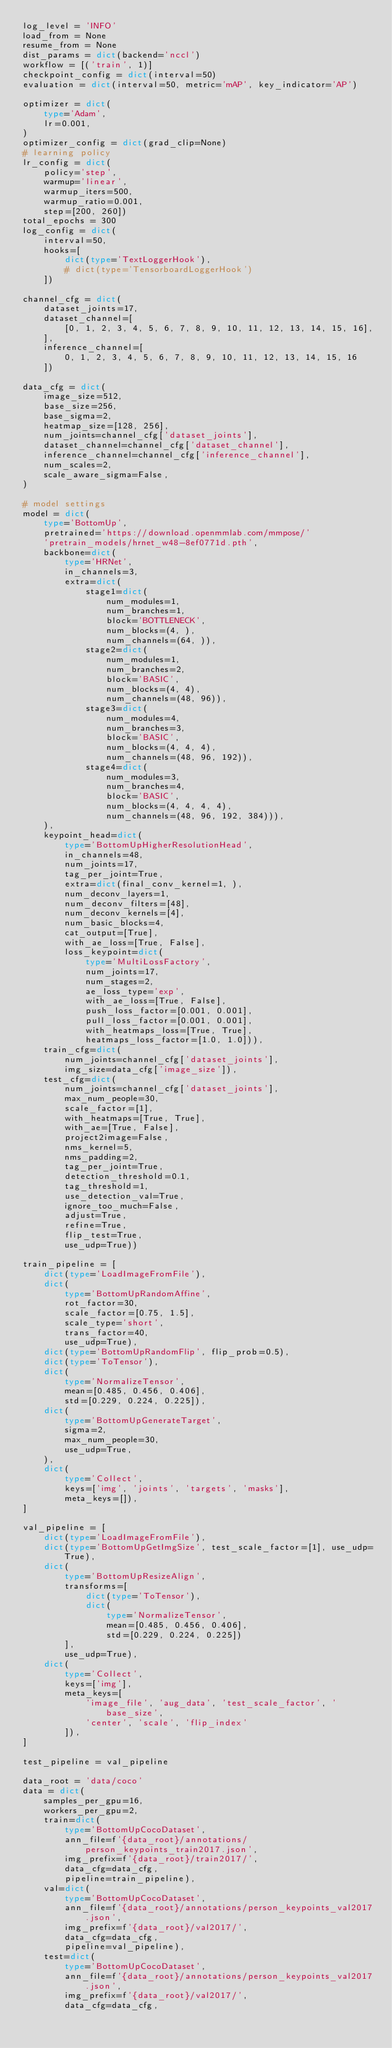<code> <loc_0><loc_0><loc_500><loc_500><_Python_>log_level = 'INFO'
load_from = None
resume_from = None
dist_params = dict(backend='nccl')
workflow = [('train', 1)]
checkpoint_config = dict(interval=50)
evaluation = dict(interval=50, metric='mAP', key_indicator='AP')

optimizer = dict(
    type='Adam',
    lr=0.001,
)
optimizer_config = dict(grad_clip=None)
# learning policy
lr_config = dict(
    policy='step',
    warmup='linear',
    warmup_iters=500,
    warmup_ratio=0.001,
    step=[200, 260])
total_epochs = 300
log_config = dict(
    interval=50,
    hooks=[
        dict(type='TextLoggerHook'),
        # dict(type='TensorboardLoggerHook')
    ])

channel_cfg = dict(
    dataset_joints=17,
    dataset_channel=[
        [0, 1, 2, 3, 4, 5, 6, 7, 8, 9, 10, 11, 12, 13, 14, 15, 16],
    ],
    inference_channel=[
        0, 1, 2, 3, 4, 5, 6, 7, 8, 9, 10, 11, 12, 13, 14, 15, 16
    ])

data_cfg = dict(
    image_size=512,
    base_size=256,
    base_sigma=2,
    heatmap_size=[128, 256],
    num_joints=channel_cfg['dataset_joints'],
    dataset_channel=channel_cfg['dataset_channel'],
    inference_channel=channel_cfg['inference_channel'],
    num_scales=2,
    scale_aware_sigma=False,
)

# model settings
model = dict(
    type='BottomUp',
    pretrained='https://download.openmmlab.com/mmpose/'
    'pretrain_models/hrnet_w48-8ef0771d.pth',
    backbone=dict(
        type='HRNet',
        in_channels=3,
        extra=dict(
            stage1=dict(
                num_modules=1,
                num_branches=1,
                block='BOTTLENECK',
                num_blocks=(4, ),
                num_channels=(64, )),
            stage2=dict(
                num_modules=1,
                num_branches=2,
                block='BASIC',
                num_blocks=(4, 4),
                num_channels=(48, 96)),
            stage3=dict(
                num_modules=4,
                num_branches=3,
                block='BASIC',
                num_blocks=(4, 4, 4),
                num_channels=(48, 96, 192)),
            stage4=dict(
                num_modules=3,
                num_branches=4,
                block='BASIC',
                num_blocks=(4, 4, 4, 4),
                num_channels=(48, 96, 192, 384))),
    ),
    keypoint_head=dict(
        type='BottomUpHigherResolutionHead',
        in_channels=48,
        num_joints=17,
        tag_per_joint=True,
        extra=dict(final_conv_kernel=1, ),
        num_deconv_layers=1,
        num_deconv_filters=[48],
        num_deconv_kernels=[4],
        num_basic_blocks=4,
        cat_output=[True],
        with_ae_loss=[True, False],
        loss_keypoint=dict(
            type='MultiLossFactory',
            num_joints=17,
            num_stages=2,
            ae_loss_type='exp',
            with_ae_loss=[True, False],
            push_loss_factor=[0.001, 0.001],
            pull_loss_factor=[0.001, 0.001],
            with_heatmaps_loss=[True, True],
            heatmaps_loss_factor=[1.0, 1.0])),
    train_cfg=dict(
        num_joints=channel_cfg['dataset_joints'],
        img_size=data_cfg['image_size']),
    test_cfg=dict(
        num_joints=channel_cfg['dataset_joints'],
        max_num_people=30,
        scale_factor=[1],
        with_heatmaps=[True, True],
        with_ae=[True, False],
        project2image=False,
        nms_kernel=5,
        nms_padding=2,
        tag_per_joint=True,
        detection_threshold=0.1,
        tag_threshold=1,
        use_detection_val=True,
        ignore_too_much=False,
        adjust=True,
        refine=True,
        flip_test=True,
        use_udp=True))

train_pipeline = [
    dict(type='LoadImageFromFile'),
    dict(
        type='BottomUpRandomAffine',
        rot_factor=30,
        scale_factor=[0.75, 1.5],
        scale_type='short',
        trans_factor=40,
        use_udp=True),
    dict(type='BottomUpRandomFlip', flip_prob=0.5),
    dict(type='ToTensor'),
    dict(
        type='NormalizeTensor',
        mean=[0.485, 0.456, 0.406],
        std=[0.229, 0.224, 0.225]),
    dict(
        type='BottomUpGenerateTarget',
        sigma=2,
        max_num_people=30,
        use_udp=True,
    ),
    dict(
        type='Collect',
        keys=['img', 'joints', 'targets', 'masks'],
        meta_keys=[]),
]

val_pipeline = [
    dict(type='LoadImageFromFile'),
    dict(type='BottomUpGetImgSize', test_scale_factor=[1], use_udp=True),
    dict(
        type='BottomUpResizeAlign',
        transforms=[
            dict(type='ToTensor'),
            dict(
                type='NormalizeTensor',
                mean=[0.485, 0.456, 0.406],
                std=[0.229, 0.224, 0.225])
        ],
        use_udp=True),
    dict(
        type='Collect',
        keys=['img'],
        meta_keys=[
            'image_file', 'aug_data', 'test_scale_factor', 'base_size',
            'center', 'scale', 'flip_index'
        ]),
]

test_pipeline = val_pipeline

data_root = 'data/coco'
data = dict(
    samples_per_gpu=16,
    workers_per_gpu=2,
    train=dict(
        type='BottomUpCocoDataset',
        ann_file=f'{data_root}/annotations/person_keypoints_train2017.json',
        img_prefix=f'{data_root}/train2017/',
        data_cfg=data_cfg,
        pipeline=train_pipeline),
    val=dict(
        type='BottomUpCocoDataset',
        ann_file=f'{data_root}/annotations/person_keypoints_val2017.json',
        img_prefix=f'{data_root}/val2017/',
        data_cfg=data_cfg,
        pipeline=val_pipeline),
    test=dict(
        type='BottomUpCocoDataset',
        ann_file=f'{data_root}/annotations/person_keypoints_val2017.json',
        img_prefix=f'{data_root}/val2017/',
        data_cfg=data_cfg,</code> 